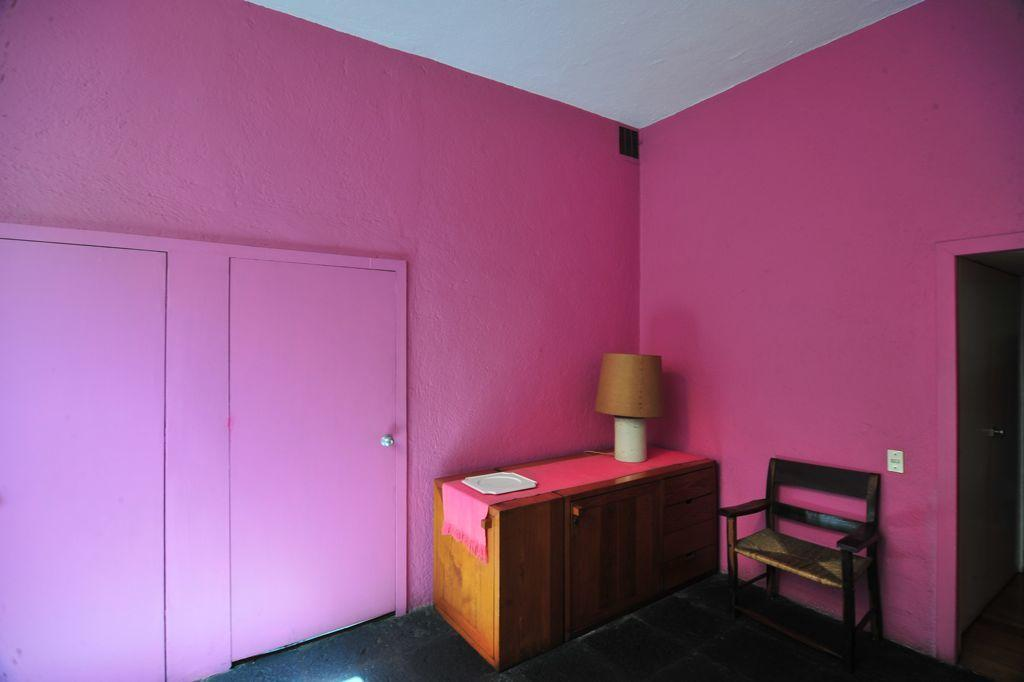What color is the wall in the image? The wall is painted pink. What can be found on the wall in the image? There are doors in the image. What type of furniture is present in the image? There is a chair in the image. What objects are on the table in the image? There is a lamp and a plate on the table in the image. What color is the ceiling in the image? The ceiling is white in color. How many bulbs are present in the image? There is no mention of bulbs in the image; only a lamp is mentioned. Can you see a goat in the image? There is no goat present in the image. 